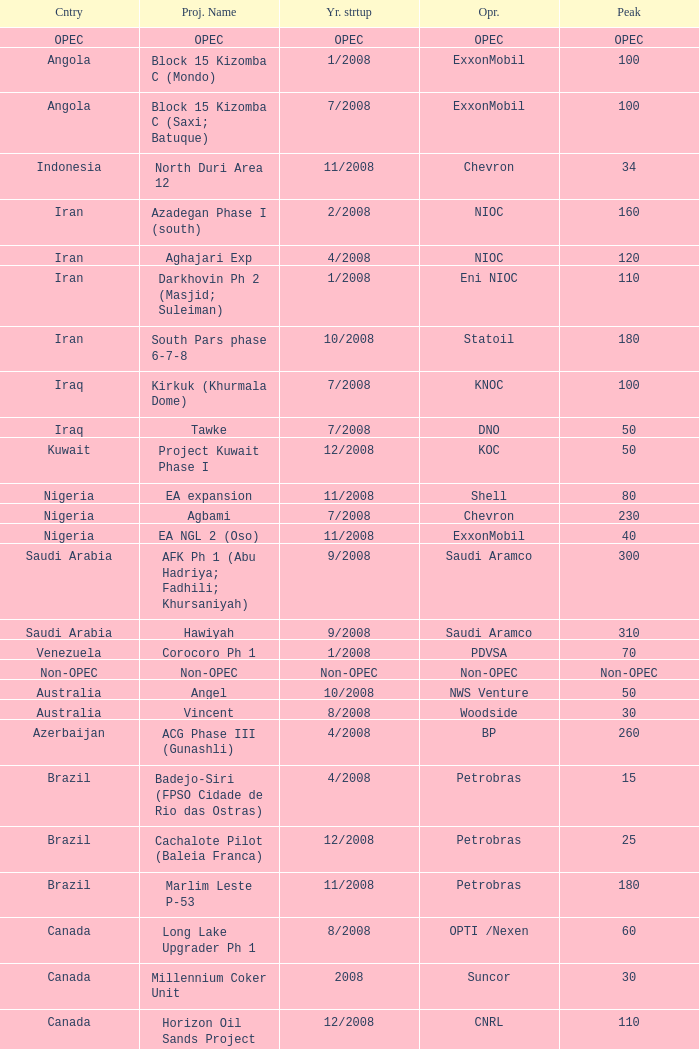What is the Operator with a Peak that is 55? PEMEX. 